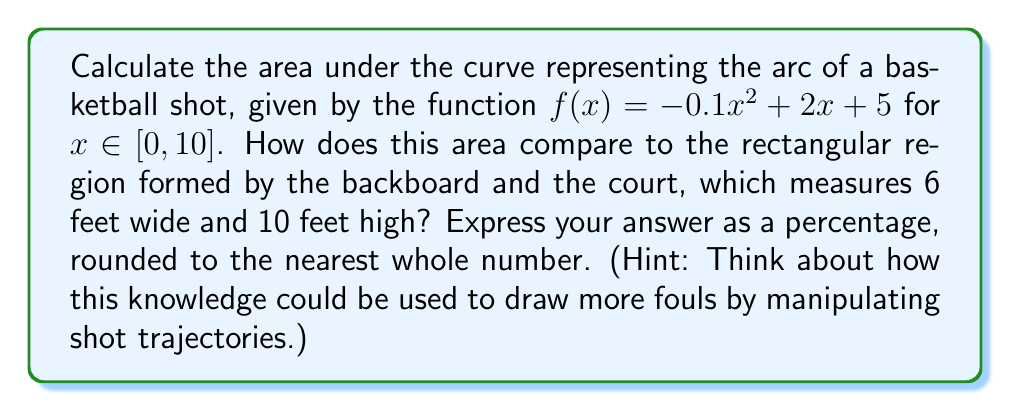Help me with this question. 1) To find the area under the curve, we need to integrate $f(x)$ from 0 to 10:

   $$A = \int_0^{10} (-0.1x^2 + 2x + 5) dx$$

2) Integrate term by term:
   $$A = [-\frac{0.1x^3}{3} + x^2 + 5x]_0^{10}$$

3) Evaluate the integral:
   $$A = [-\frac{0.1(1000)}{3} + 100 + 50] - [0 + 0 + 0]$$
   $$A = -33.33 + 100 + 50 = 116.67$$

4) The area under the curve is approximately 116.67 square feet.

5) The area of the rectangular region (backboard and court):
   $$A_{rectangle} = 6 \times 10 = 60$$ square feet

6) Calculate the percentage:
   $$\text{Percentage} = \frac{116.67}{60} \times 100 \approx 194.45\%$$

7) Rounded to the nearest whole number: 194%

This larger area suggests a higher arc, which could be used to draw more fouls by creating more contact opportunities during the shot's trajectory.
Answer: 194% 